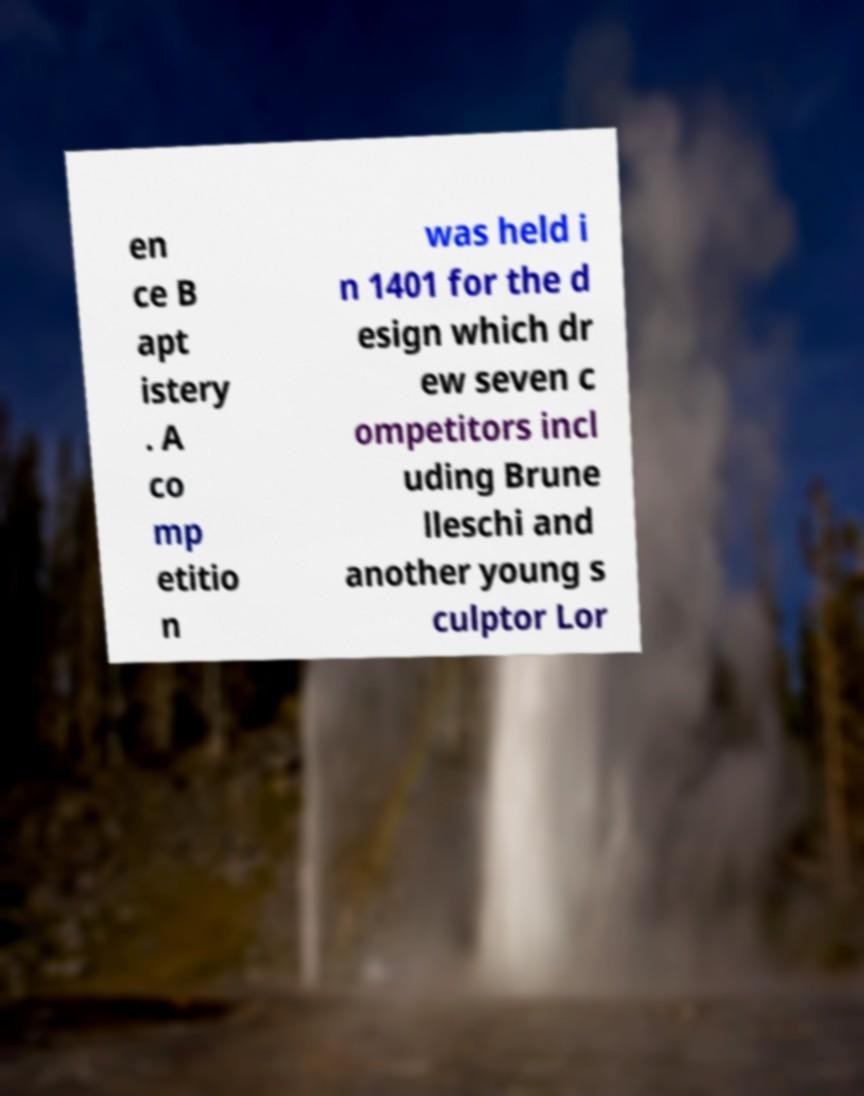Could you extract and type out the text from this image? en ce B apt istery . A co mp etitio n was held i n 1401 for the d esign which dr ew seven c ompetitors incl uding Brune lleschi and another young s culptor Lor 